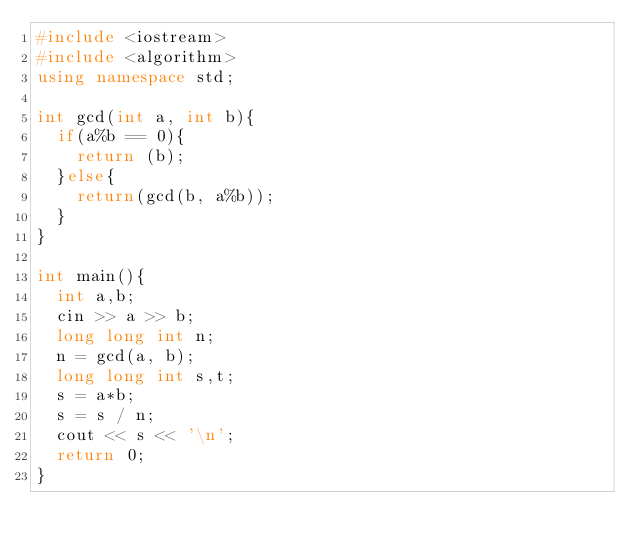Convert code to text. <code><loc_0><loc_0><loc_500><loc_500><_C++_>#include <iostream>
#include <algorithm>
using namespace std;

int gcd(int a, int b){
  if(a%b == 0){
    return (b);
  }else{
    return(gcd(b, a%b));
  }
}

int main(){
  int a,b;
  cin >> a >> b;
  long long int n;
  n = gcd(a, b);
  long long int s,t;
  s = a*b;
  s = s / n;
  cout << s << '\n';
  return 0;
}
</code> 